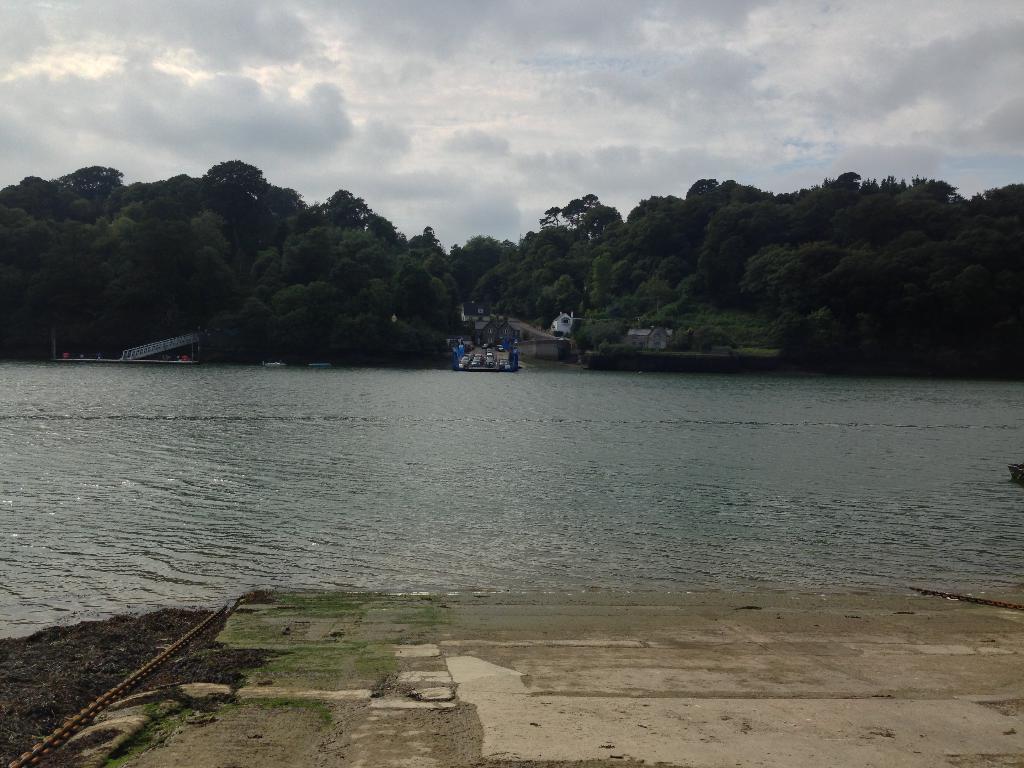In one or two sentences, can you explain what this image depicts? In this image in front there is water. In the background of the image there are vehicles on the platform. There are buildings, trees and sky. On the left side of the image there is a bridge. 